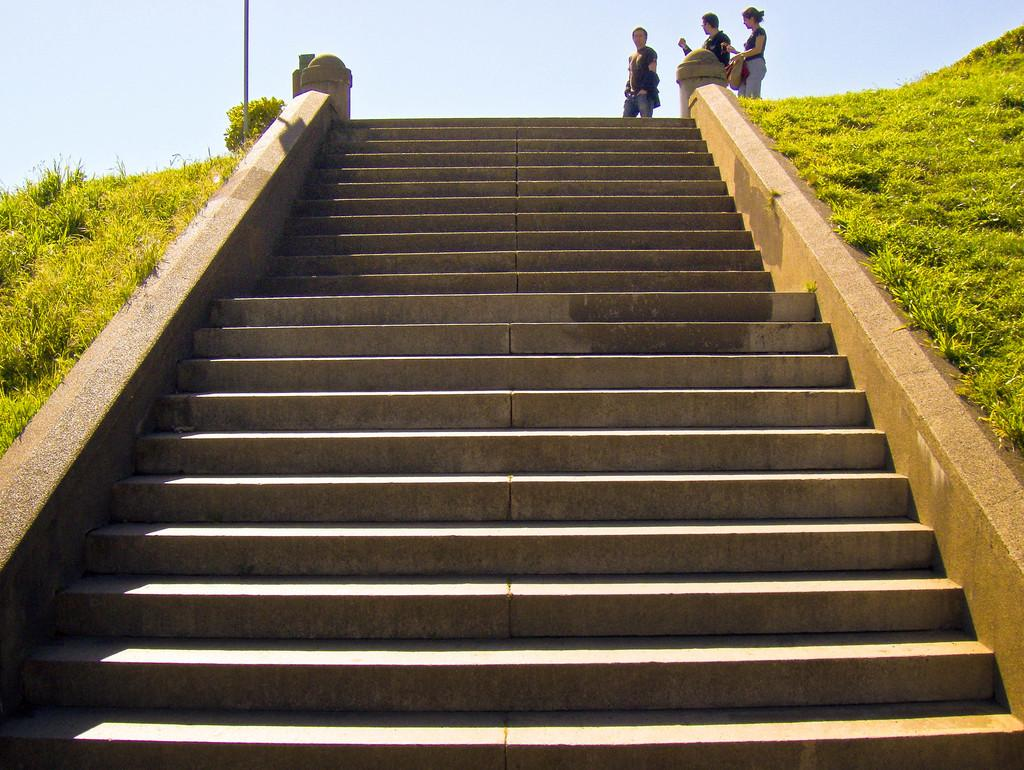What type of structure can be seen in the image? There are stairs in the image, which suggests a structure or building. What type of natural environment is visible in the image? There is grass and plants in the image, indicating a natural setting. How many people are present in the image? There are three persons standing in the image. What is visible in the background of the image? There is sky visible in the background of the image. What type of society is depicted in the image? There is no specific society depicted in the image; it features stairs, grass, plants, and three persons standing. What type of destruction can be seen in the image? There is no destruction present in the image; it is a natural and peaceful scene. 